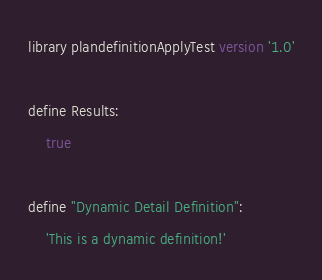<code> <loc_0><loc_0><loc_500><loc_500><_SQL_>library plandefinitionApplyTest version '1.0'

define Results:
    true

define "Dynamic Detail Definition":
    'This is a dynamic definition!'</code> 